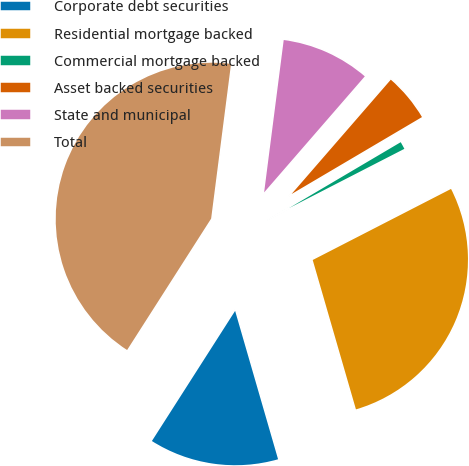Convert chart. <chart><loc_0><loc_0><loc_500><loc_500><pie_chart><fcel>Corporate debt securities<fcel>Residential mortgage backed<fcel>Commercial mortgage backed<fcel>Asset backed securities<fcel>State and municipal<fcel>Total<nl><fcel>13.54%<fcel>28.07%<fcel>0.93%<fcel>5.14%<fcel>9.34%<fcel>42.98%<nl></chart> 